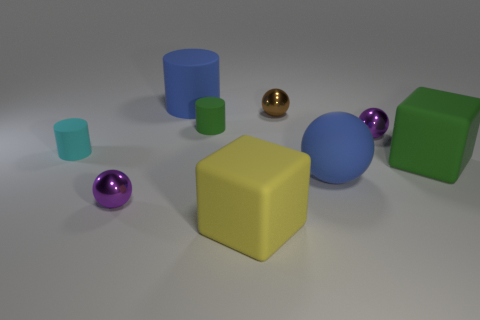Can you tell me about the different textures visible in this image? Certainly! The image showcases a variety of textures. The yellow cube in the center has a matte finish, diffusing light evenly. In contrast, the golden sphere and the two purple spheres have reflective, shiny surfaces. The green objects, both the cube and the cylinder, exhibit a slightly less reflective matte surface than the yellow one, and they also have a smooth appearance. 